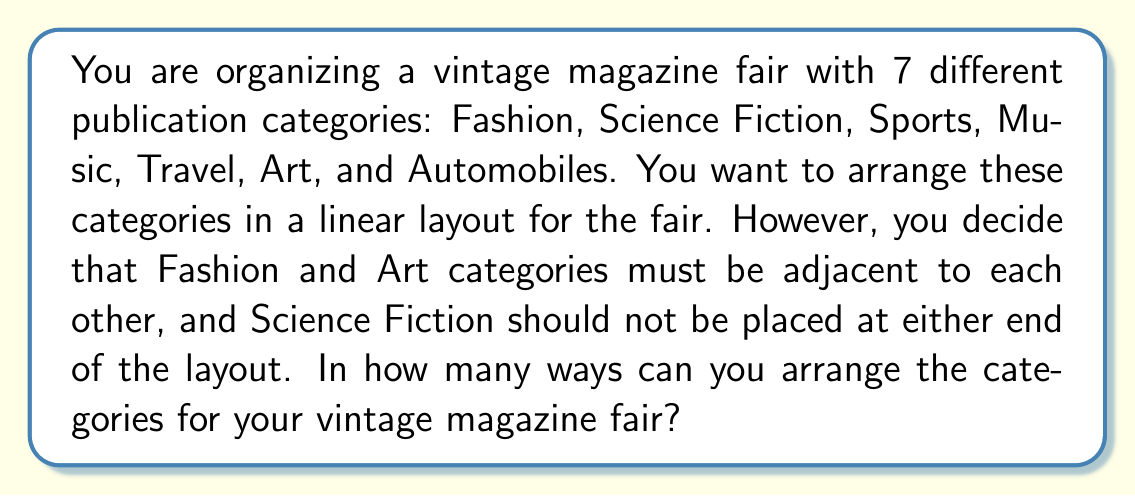Teach me how to tackle this problem. Let's approach this problem step by step:

1) First, we need to consider Fashion and Art as one unit since they must be adjacent. This reduces our problem from 7 elements to 6 elements (Fashion-Art unit, Science Fiction, Sports, Music, Travel, and Automobiles).

2) We know that Science Fiction cannot be at either end. This means we have 4 positions where Science Fiction can be placed (2nd, 3rd, 4th, or 5th position in a 6-element arrangement).

3) For each position of Science Fiction, we need to arrange the other 5 elements (including the Fashion-Art unit as one element).

4) The number of ways to arrange 5 elements is 5! = 5 × 4 × 3 × 2 × 1 = 120.

5) Since Science Fiction can be in 4 different positions, and for each of these positions, we have 120 ways to arrange the other elements, we multiply:

   $$ 4 \times 120 = 480 $$

6) However, we're not done yet. Remember that Fashion and Art can be swapped within their unit. This doubles our total number of arrangements.

Therefore, the final number of possible arrangements is:

$$ 480 \times 2 = 960 $$
Answer: 960 ways 